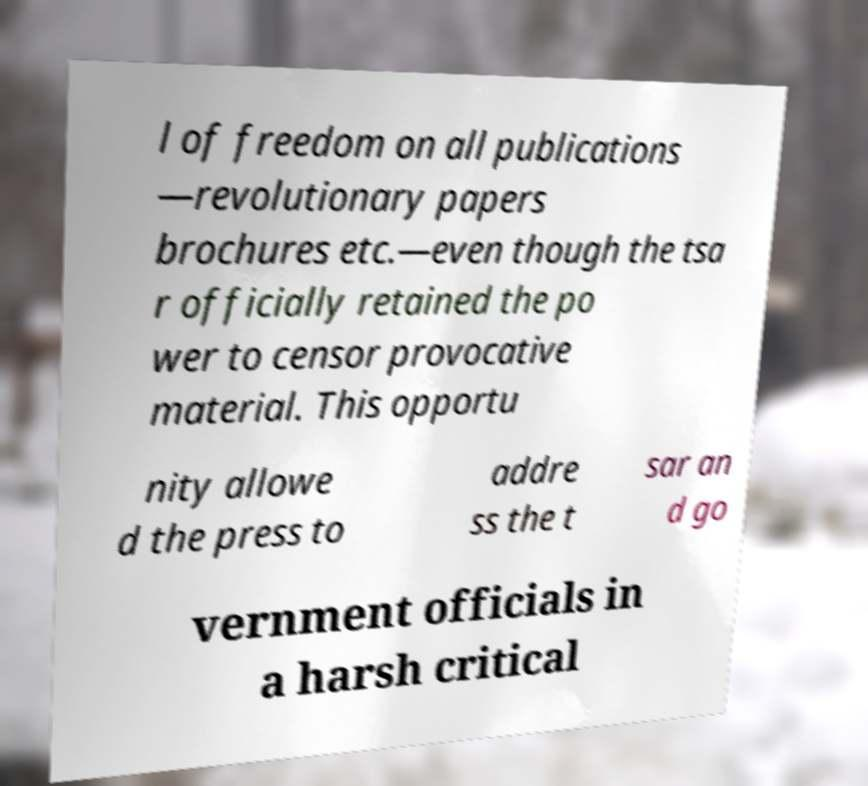There's text embedded in this image that I need extracted. Can you transcribe it verbatim? l of freedom on all publications —revolutionary papers brochures etc.—even though the tsa r officially retained the po wer to censor provocative material. This opportu nity allowe d the press to addre ss the t sar an d go vernment officials in a harsh critical 